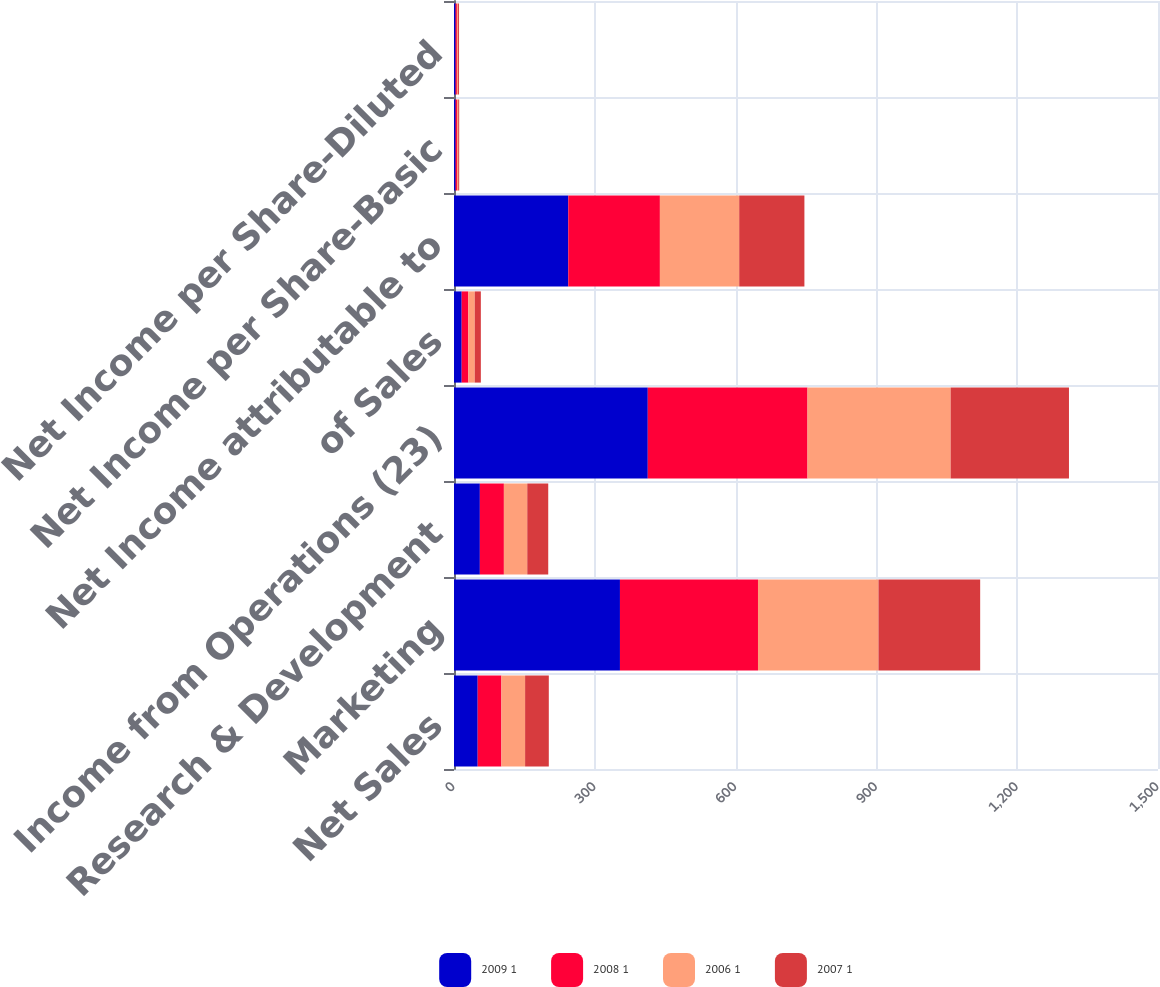Convert chart to OTSL. <chart><loc_0><loc_0><loc_500><loc_500><stacked_bar_chart><ecel><fcel>Net Sales<fcel>Marketing<fcel>Research & Development<fcel>Income from Operations (23)<fcel>of Sales<fcel>Net Income attributable to<fcel>Net Income per Share-Basic<fcel>Net Income per Share-Diluted<nl><fcel>2009 1<fcel>50.5<fcel>353.6<fcel>55.1<fcel>412.9<fcel>16.4<fcel>243.5<fcel>3.46<fcel>3.41<nl><fcel>2008 1<fcel>50.5<fcel>294.1<fcel>51.2<fcel>340.3<fcel>14.1<fcel>195.2<fcel>2.88<fcel>2.78<nl><fcel>2006 1<fcel>50.5<fcel>256.7<fcel>49.8<fcel>305<fcel>13.7<fcel>169<fcel>2.57<fcel>2.46<nl><fcel>2007 1<fcel>50.5<fcel>216.7<fcel>44.7<fcel>252.1<fcel>13<fcel>138.9<fcel>2.14<fcel>2.07<nl></chart> 